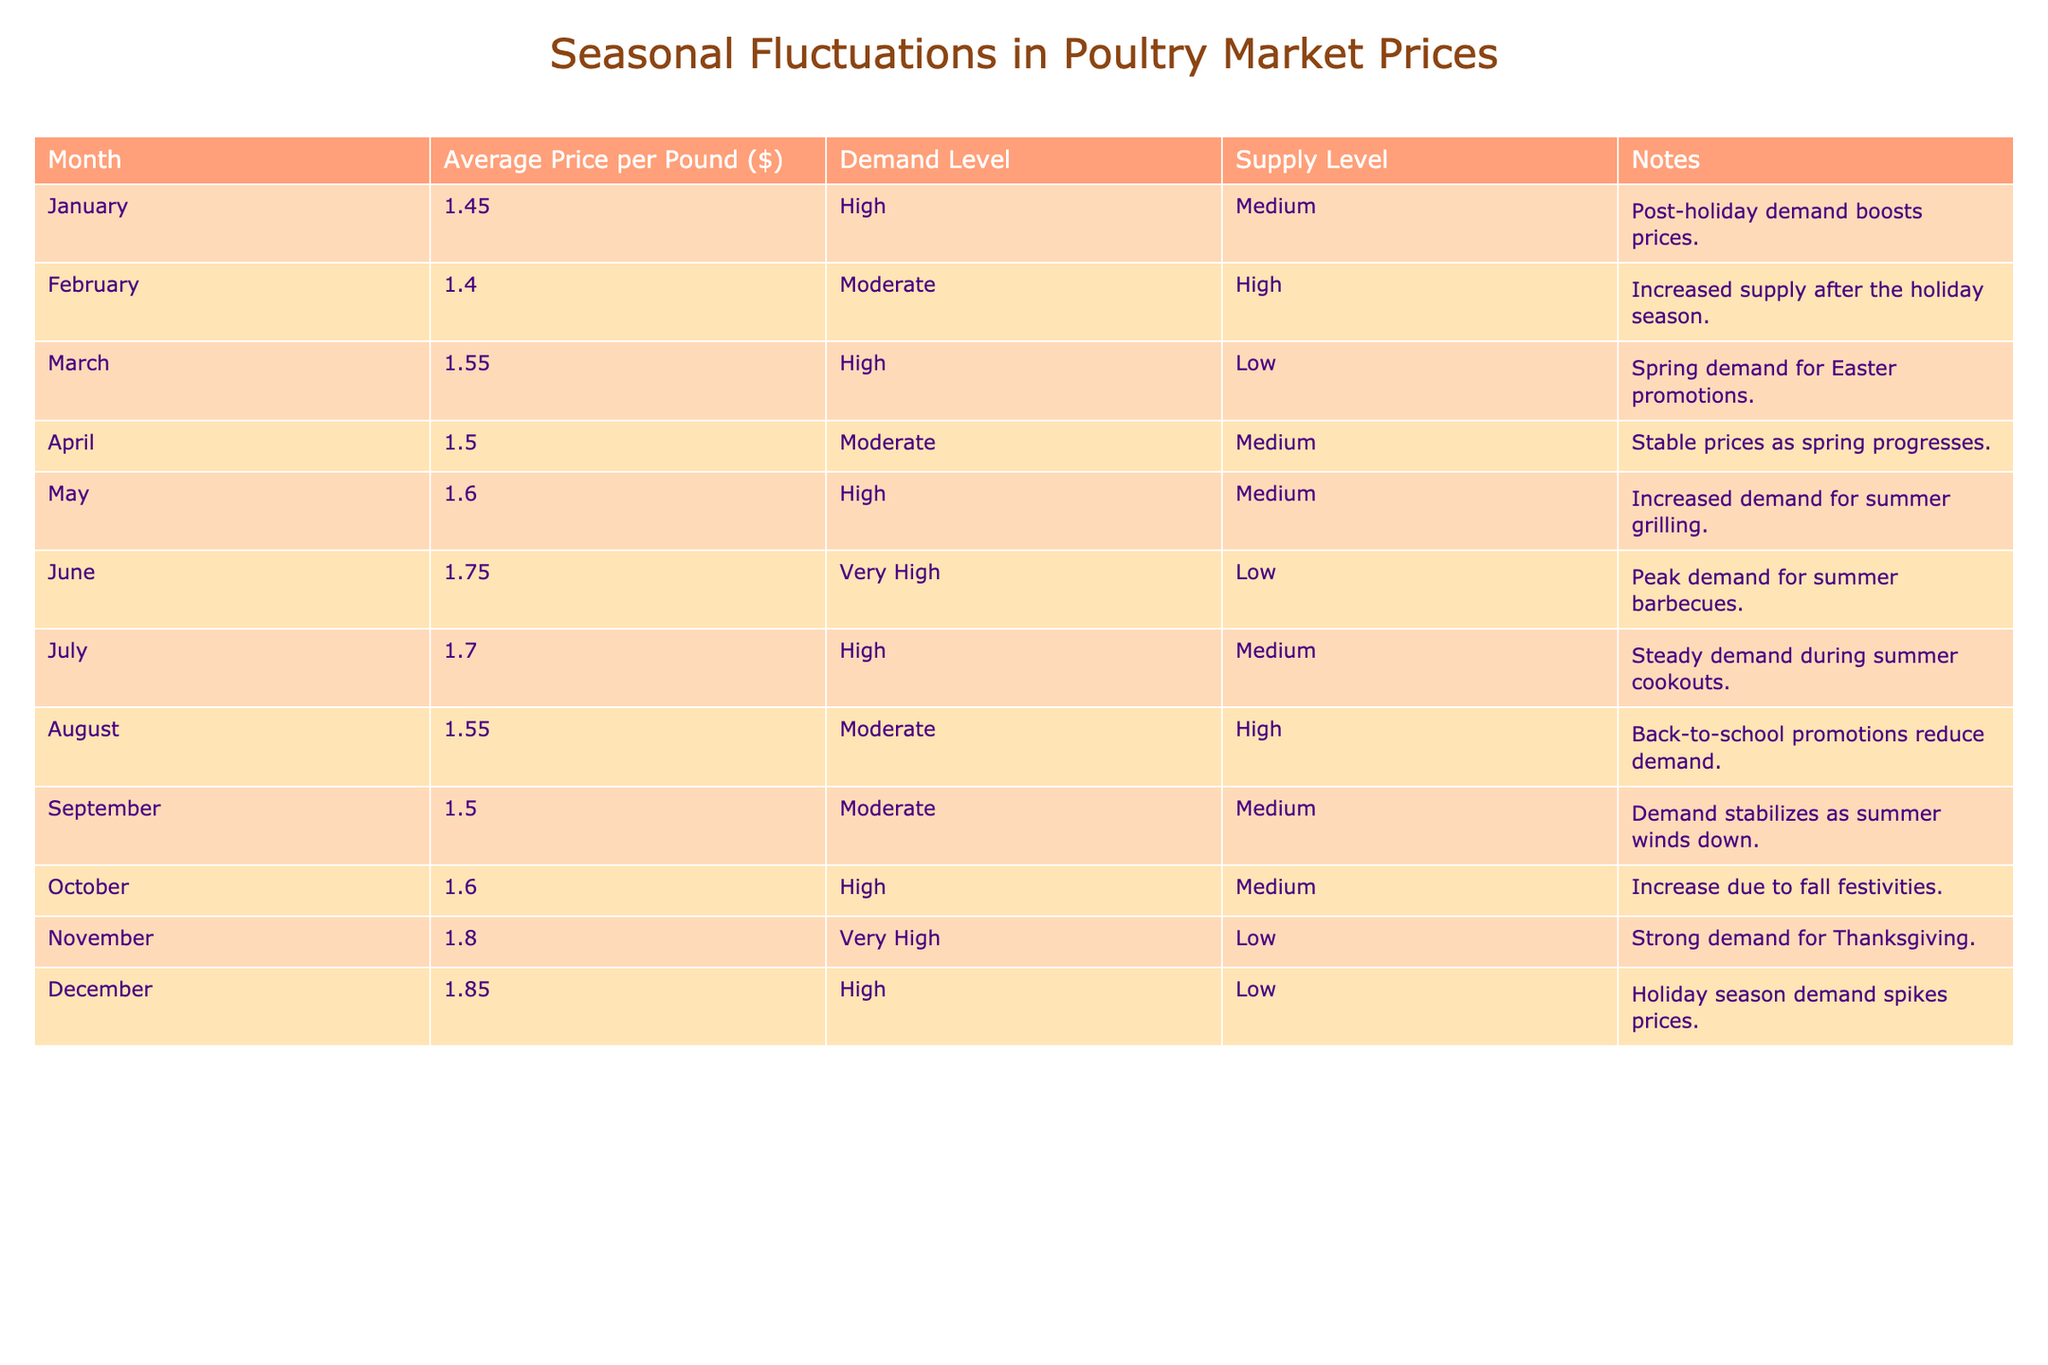What is the average price per pound in December? The table shows that the average price per pound in December is 1.85.
Answer: 1.85 In which month did the poultry market experience the highest average price per pound? The table indicates that the highest average price per pound is in November at 1.80.
Answer: November What is the change in average price per pound from March to April? The average price per pound in March is 1.55, and in April, it is 1.50. The change is 1.50 - 1.55 = -0.05.
Answer: -0.05 How many months had a high demand level and also a high average price per pound? The months with high demand levels that also have high average prices per pound are January (1.45), March (1.55), May (1.60), June (1.75), October (1.60), and November (1.80). This gives a total of 6 months.
Answer: 6 Is the average price per pound in August lower than the average price per pound in February? The average price per pound in August is 1.55, while in February it is 1.40. Therefore, the average price in August is higher than in February.
Answer: No Which month had the lowest supply level and what was the average price per pound that month? The months with low supply levels are March, June, November, and December. The average prices for those months are 1.55 (March), 1.75 (June), 1.80 (November), and 1.85 (December). The lowest supply level was in March at an average price of 1.55.
Answer: 1.55 (March) What is the average price per pound for the months with very high demand levels? The months with very high demand levels are June (1.75) and November (1.80). To find the average, sum these prices: 1.75 + 1.80 = 3.55, then divide by 2 for the average: 3.55 / 2 = 1.775.
Answer: 1.775 In which month does the poultry market see a price increase due to fall festivities, and what is that price? The month that sees a price increase due to fall festivities is October, with an average price of 1.60.
Answer: October, 1.60 What is the highest average price per pound in the second half of the year? The table shows that the average prices in the second half of the year are 1.55 (August), 1.50 (September), 1.60 (October), 1.80 (November), and 1.85 (December). The highest price among these is 1.85 in December.
Answer: 1.85 